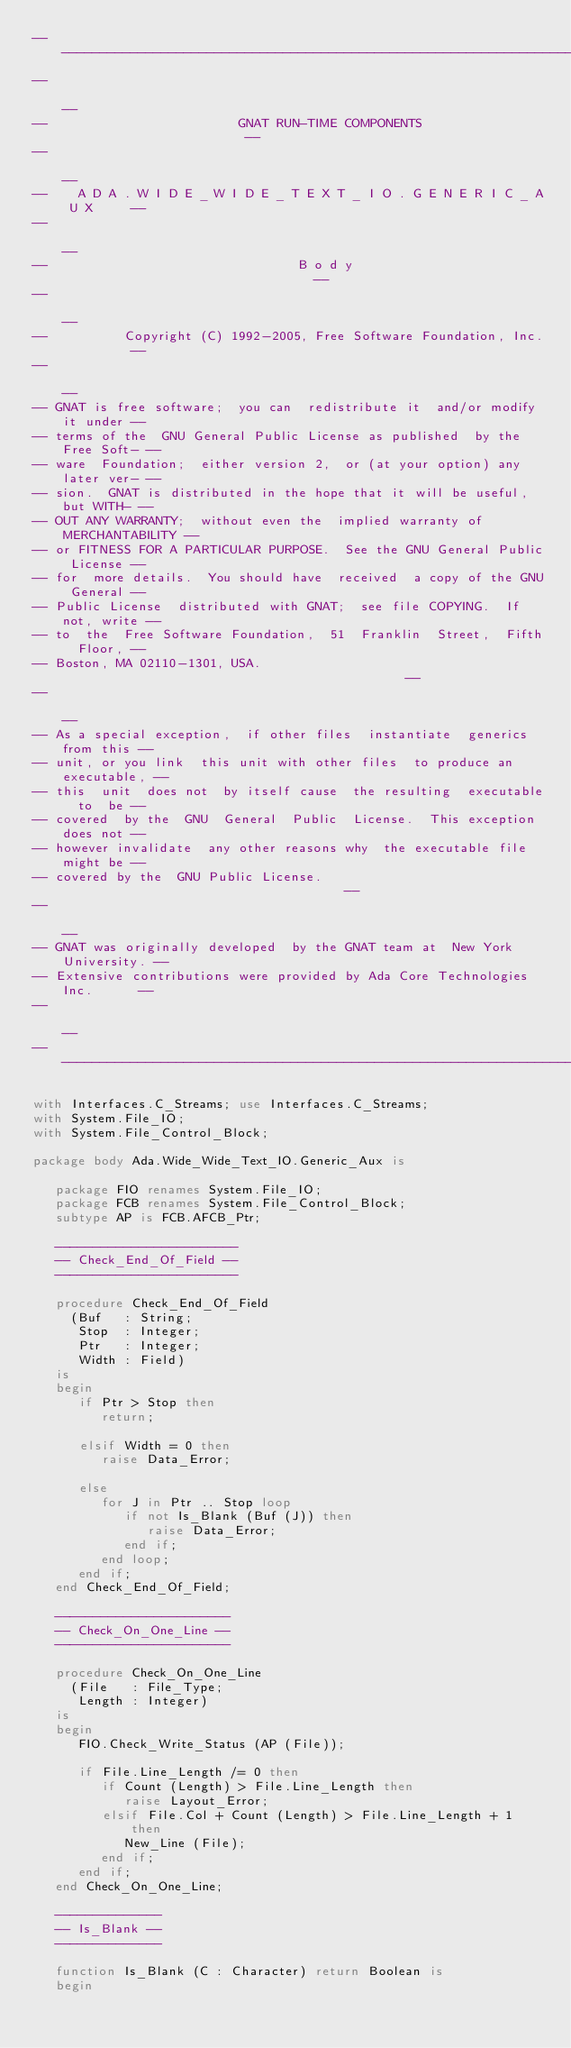Convert code to text. <code><loc_0><loc_0><loc_500><loc_500><_Ada_>------------------------------------------------------------------------------
--                                                                          --
--                         GNAT RUN-TIME COMPONENTS                         --
--                                                                          --
--    A D A . W I D E _ W I D E _ T E X T _ I O . G E N E R I C _ A U X     --
--                                                                          --
--                                 B o d y                                  --
--                                                                          --
--          Copyright (C) 1992-2005, Free Software Foundation, Inc.         --
--                                                                          --
-- GNAT is free software;  you can  redistribute it  and/or modify it under --
-- terms of the  GNU General Public License as published  by the Free Soft- --
-- ware  Foundation;  either version 2,  or (at your option) any later ver- --
-- sion.  GNAT is distributed in the hope that it will be useful, but WITH- --
-- OUT ANY WARRANTY;  without even the  implied warranty of MERCHANTABILITY --
-- or FITNESS FOR A PARTICULAR PURPOSE.  See the GNU General Public License --
-- for  more details.  You should have  received  a copy of the GNU General --
-- Public License  distributed with GNAT;  see file COPYING.  If not, write --
-- to  the  Free Software Foundation,  51  Franklin  Street,  Fifth  Floor, --
-- Boston, MA 02110-1301, USA.                                              --
--                                                                          --
-- As a special exception,  if other files  instantiate  generics from this --
-- unit, or you link  this unit with other files  to produce an executable, --
-- this  unit  does not  by itself cause  the resulting  executable  to  be --
-- covered  by the  GNU  General  Public  License.  This exception does not --
-- however invalidate  any other reasons why  the executable file  might be --
-- covered by the  GNU Public License.                                      --
--                                                                          --
-- GNAT was originally developed  by the GNAT team at  New York University. --
-- Extensive contributions were provided by Ada Core Technologies Inc.      --
--                                                                          --
------------------------------------------------------------------------------

with Interfaces.C_Streams; use Interfaces.C_Streams;
with System.File_IO;
with System.File_Control_Block;

package body Ada.Wide_Wide_Text_IO.Generic_Aux is

   package FIO renames System.File_IO;
   package FCB renames System.File_Control_Block;
   subtype AP is FCB.AFCB_Ptr;

   ------------------------
   -- Check_End_Of_Field --
   ------------------------

   procedure Check_End_Of_Field
     (Buf   : String;
      Stop  : Integer;
      Ptr   : Integer;
      Width : Field)
   is
   begin
      if Ptr > Stop then
         return;

      elsif Width = 0 then
         raise Data_Error;

      else
         for J in Ptr .. Stop loop
            if not Is_Blank (Buf (J)) then
               raise Data_Error;
            end if;
         end loop;
      end if;
   end Check_End_Of_Field;

   -----------------------
   -- Check_On_One_Line --
   -----------------------

   procedure Check_On_One_Line
     (File   : File_Type;
      Length : Integer)
   is
   begin
      FIO.Check_Write_Status (AP (File));

      if File.Line_Length /= 0 then
         if Count (Length) > File.Line_Length then
            raise Layout_Error;
         elsif File.Col + Count (Length) > File.Line_Length + 1 then
            New_Line (File);
         end if;
      end if;
   end Check_On_One_Line;

   --------------
   -- Is_Blank --
   --------------

   function Is_Blank (C : Character) return Boolean is
   begin</code> 